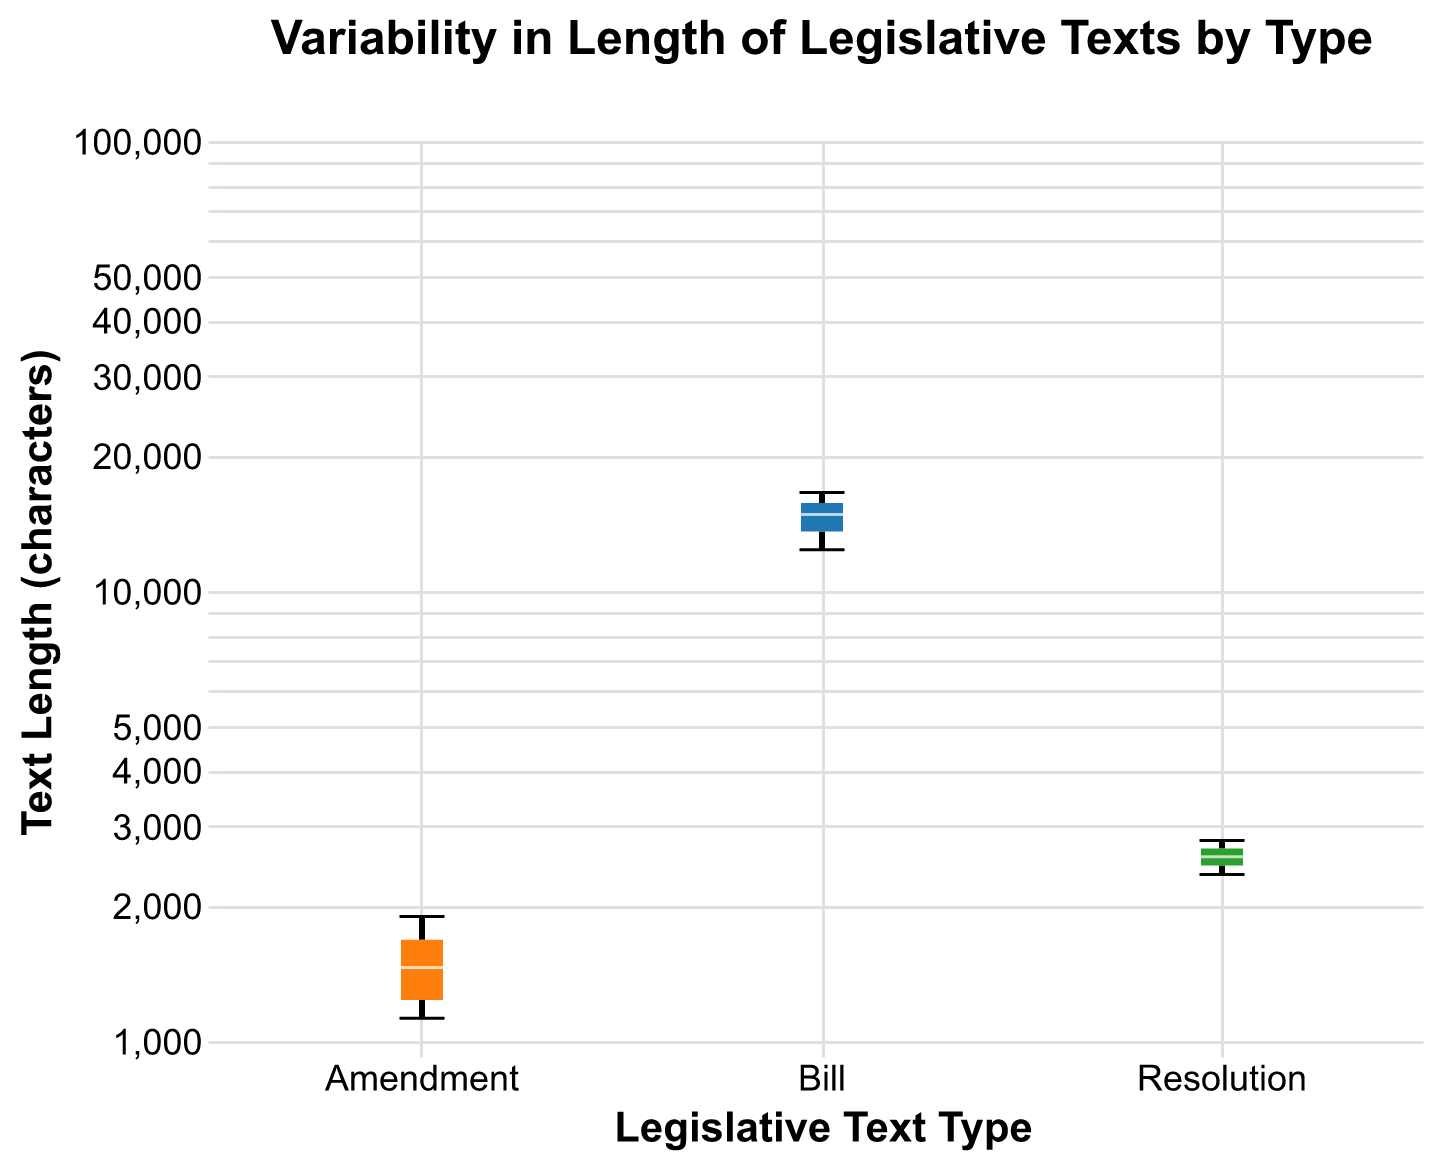What are the types of legislative texts displayed in the box plot? Identify the text categories on the x-axis labeled with different colors representing distinct groups.
Answer: Bill, Amendment, Resolution Which type of legislative text has the widest variability in length? Assess the length of whiskers (the lines extending from the boxes) in the notched box plot. The type with the longest whiskers indicates the widest variability.
Answer: Bill What is the range of lengths for amendments? Examine the top and bottom of the whiskers for the amendment box plot to determine the range.
Answer: 1123 to 1890 Which legislative text type has the shortest median length? Locate and compare the positions of the horizontal white lines within the boxes (medians) to find the shortest one.
Answer: Amendment What is the approximate median length of bills? Identify the horizontal white line within the box representing the bills and estimate its numerical position on the y-axis.
Answer: Approximately 14789 Which legislative text type shows the most consistency in lengths? Look for the box with the shortest height, indicating less variability in the dataset, and hence more consistency.
Answer: Resolution How does the median length of resolutions compare to that of bills? Compare the horizontal white lines representing the medians of resolutions and bills to determine the relationship.
Answer: The median length of resolutions is much lower than bills In which legislative text type are the lengths closest to each other? Evaluate the notches of the box plots; the smallest notch range indicates the closest lengths.
Answer: Amendment How does the median length of amendments relate to its interquartile range (IQR)? Analyze the horizontal white line in the amendment box and the height of the box (IQR) to see their relationship.
Answer: The median length of amendments is close to the upper quartile of its IQR What are the lower and upper bounds of the interquartile range (IQR) for resolutions? Identify the top and bottom edges of the resolution's box to find the first quartile (Q1) and third quartile (Q3).
Answer: Q1: 2345, Q3: 2678 